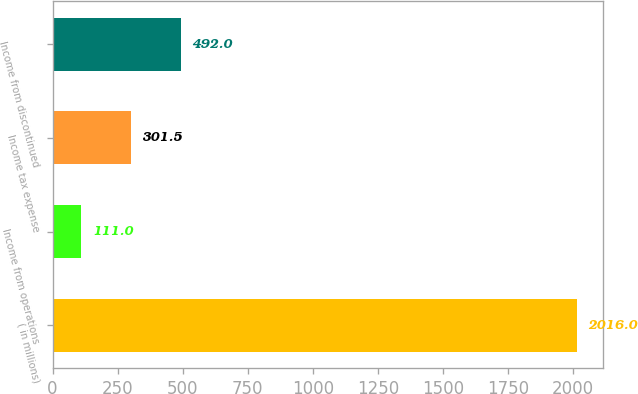Convert chart to OTSL. <chart><loc_0><loc_0><loc_500><loc_500><bar_chart><fcel>( in millions)<fcel>Income from operations<fcel>Income tax expense<fcel>Income from discontinued<nl><fcel>2016<fcel>111<fcel>301.5<fcel>492<nl></chart> 